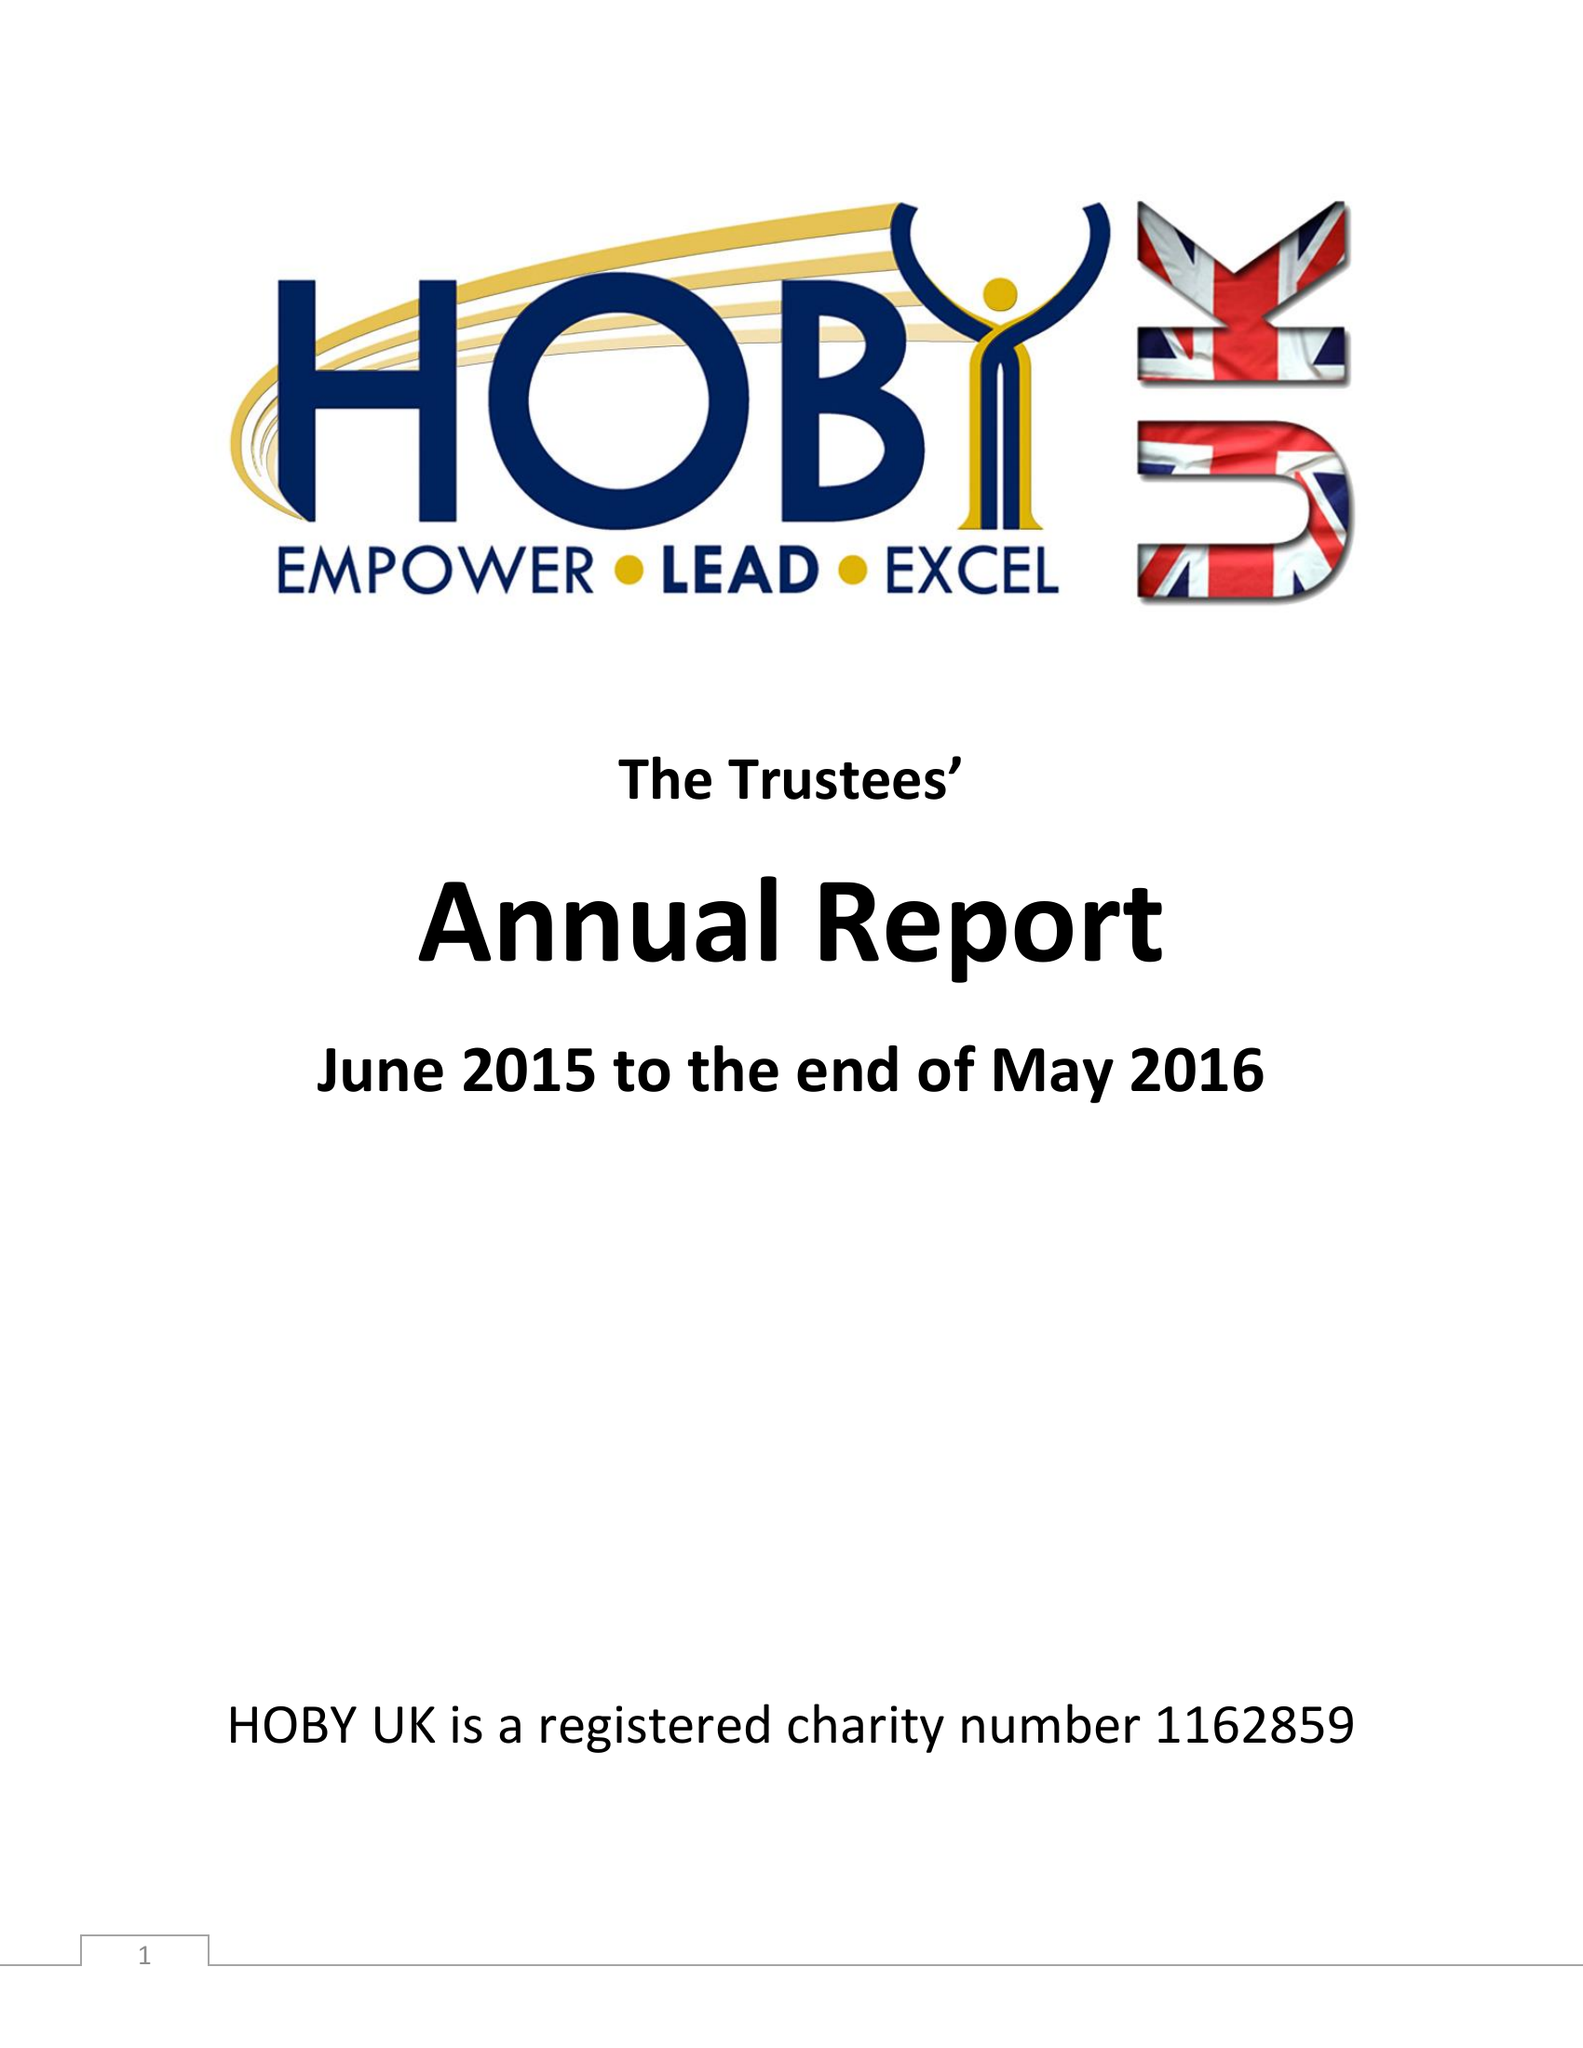What is the value for the charity_number?
Answer the question using a single word or phrase. 1162859 